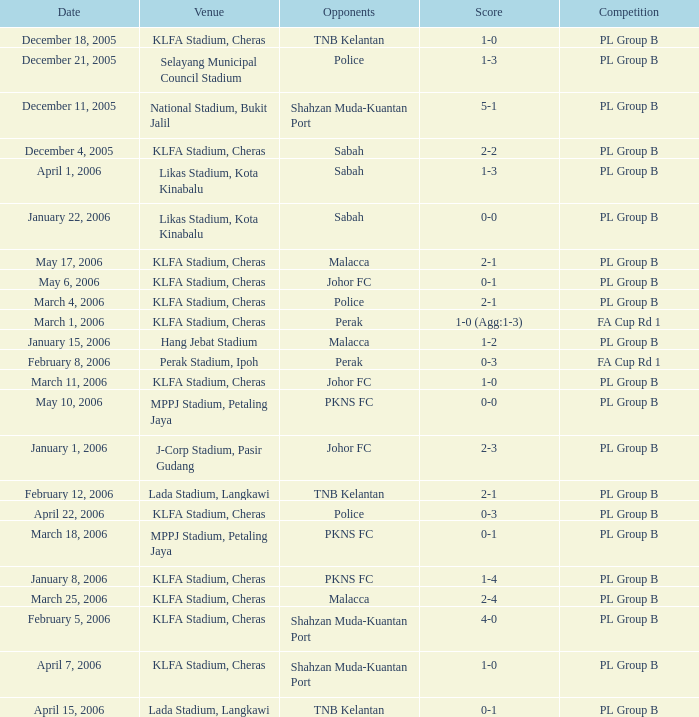Parse the table in full. {'header': ['Date', 'Venue', 'Opponents', 'Score', 'Competition'], 'rows': [['December 18, 2005', 'KLFA Stadium, Cheras', 'TNB Kelantan', '1-0', 'PL Group B'], ['December 21, 2005', 'Selayang Municipal Council Stadium', 'Police', '1-3', 'PL Group B'], ['December 11, 2005', 'National Stadium, Bukit Jalil', 'Shahzan Muda-Kuantan Port', '5-1', 'PL Group B'], ['December 4, 2005', 'KLFA Stadium, Cheras', 'Sabah', '2-2', 'PL Group B'], ['April 1, 2006', 'Likas Stadium, Kota Kinabalu', 'Sabah', '1-3', 'PL Group B'], ['January 22, 2006', 'Likas Stadium, Kota Kinabalu', 'Sabah', '0-0', 'PL Group B'], ['May 17, 2006', 'KLFA Stadium, Cheras', 'Malacca', '2-1', 'PL Group B'], ['May 6, 2006', 'KLFA Stadium, Cheras', 'Johor FC', '0-1', 'PL Group B'], ['March 4, 2006', 'KLFA Stadium, Cheras', 'Police', '2-1', 'PL Group B'], ['March 1, 2006', 'KLFA Stadium, Cheras', 'Perak', '1-0 (Agg:1-3)', 'FA Cup Rd 1'], ['January 15, 2006', 'Hang Jebat Stadium', 'Malacca', '1-2', 'PL Group B'], ['February 8, 2006', 'Perak Stadium, Ipoh', 'Perak', '0-3', 'FA Cup Rd 1'], ['March 11, 2006', 'KLFA Stadium, Cheras', 'Johor FC', '1-0', 'PL Group B'], ['May 10, 2006', 'MPPJ Stadium, Petaling Jaya', 'PKNS FC', '0-0', 'PL Group B'], ['January 1, 2006', 'J-Corp Stadium, Pasir Gudang', 'Johor FC', '2-3', 'PL Group B'], ['February 12, 2006', 'Lada Stadium, Langkawi', 'TNB Kelantan', '2-1', 'PL Group B'], ['April 22, 2006', 'KLFA Stadium, Cheras', 'Police', '0-3', 'PL Group B'], ['March 18, 2006', 'MPPJ Stadium, Petaling Jaya', 'PKNS FC', '0-1', 'PL Group B'], ['January 8, 2006', 'KLFA Stadium, Cheras', 'PKNS FC', '1-4', 'PL Group B'], ['March 25, 2006', 'KLFA Stadium, Cheras', 'Malacca', '2-4', 'PL Group B'], ['February 5, 2006', 'KLFA Stadium, Cheras', 'Shahzan Muda-Kuantan Port', '4-0', 'PL Group B'], ['April 7, 2006', 'KLFA Stadium, Cheras', 'Shahzan Muda-Kuantan Port', '1-0', 'PL Group B'], ['April 15, 2006', 'Lada Stadium, Langkawi', 'TNB Kelantan', '0-1', 'PL Group B']]} Which tournament features a 0-1 score, and rivals of pkns fc? PL Group B. 